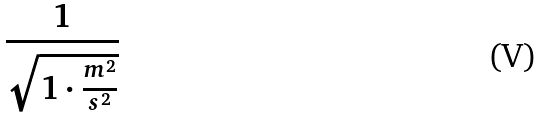<formula> <loc_0><loc_0><loc_500><loc_500>\frac { 1 } { \sqrt { 1 \cdot \frac { m ^ { 2 } } { s ^ { 2 } } } }</formula> 